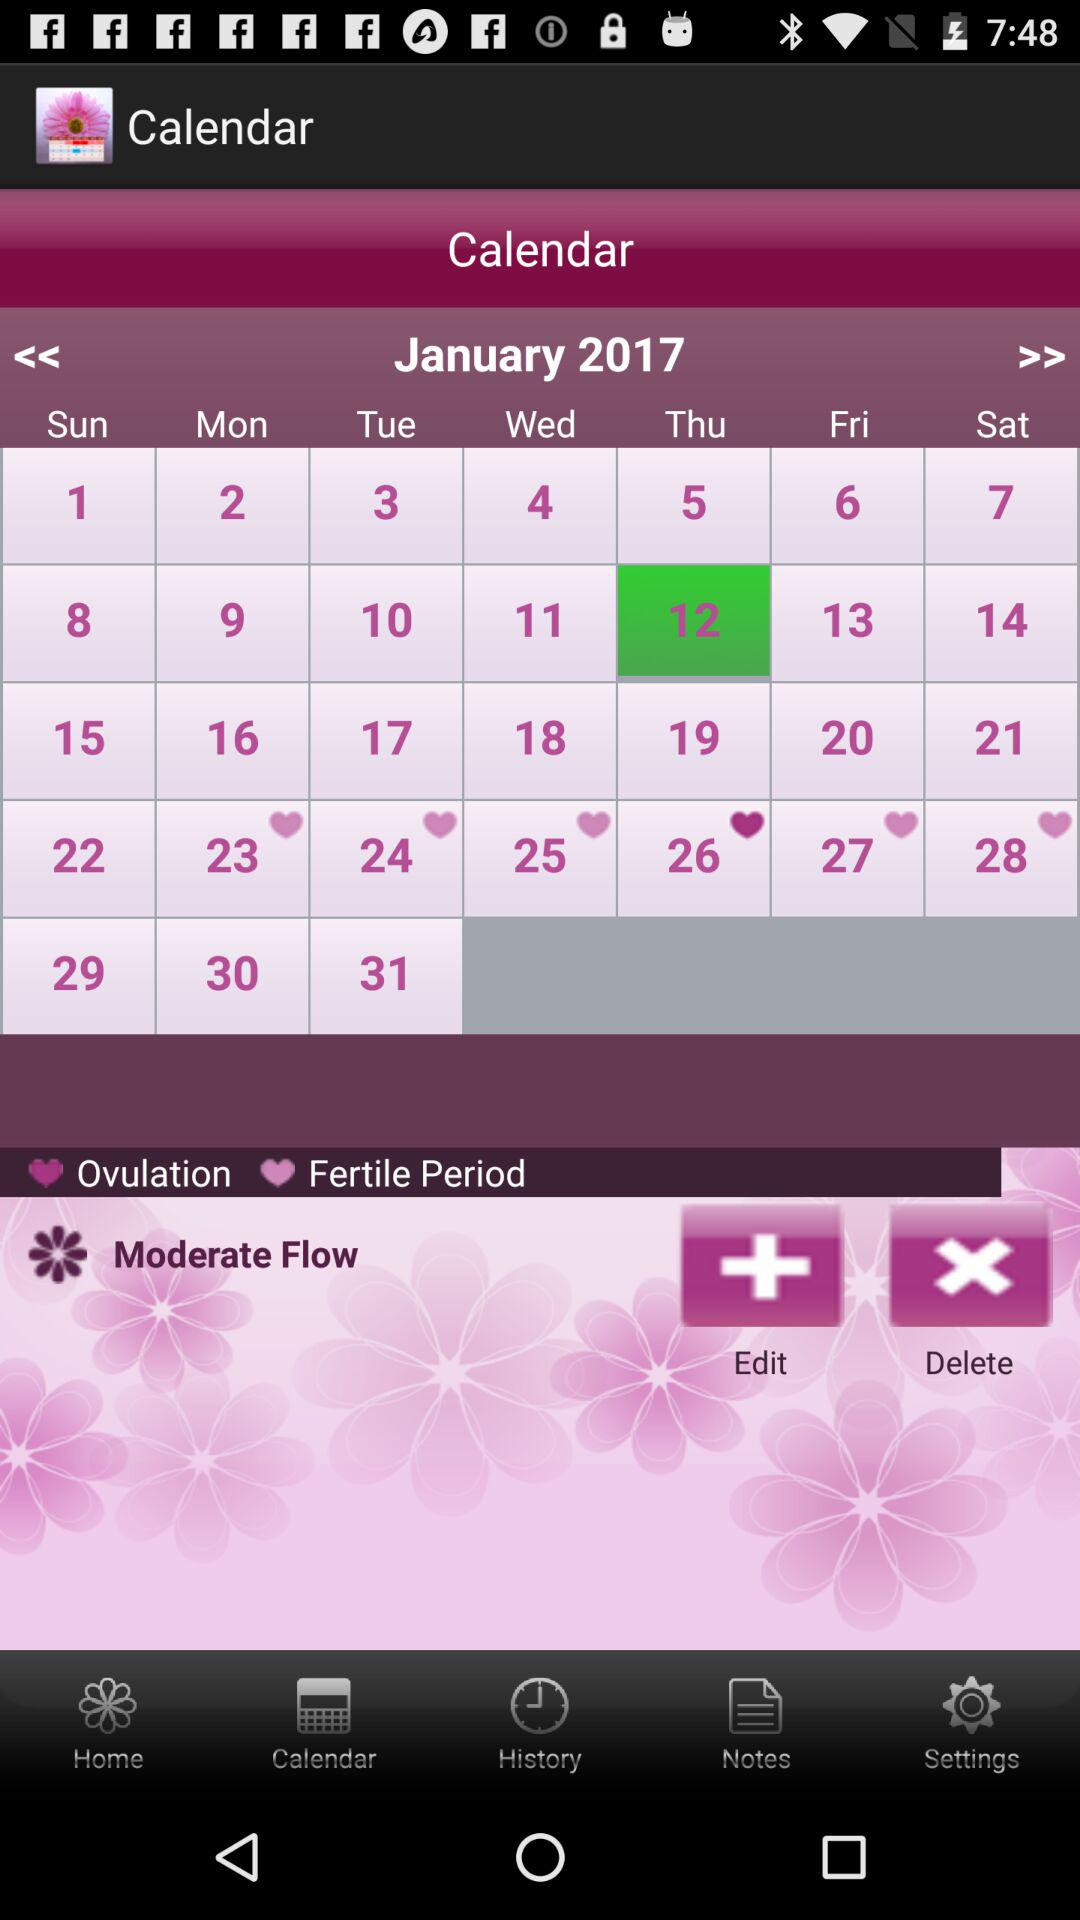Which date is highlighted for ovulation? The highlighted date is Thursday, January 26, 2017. 